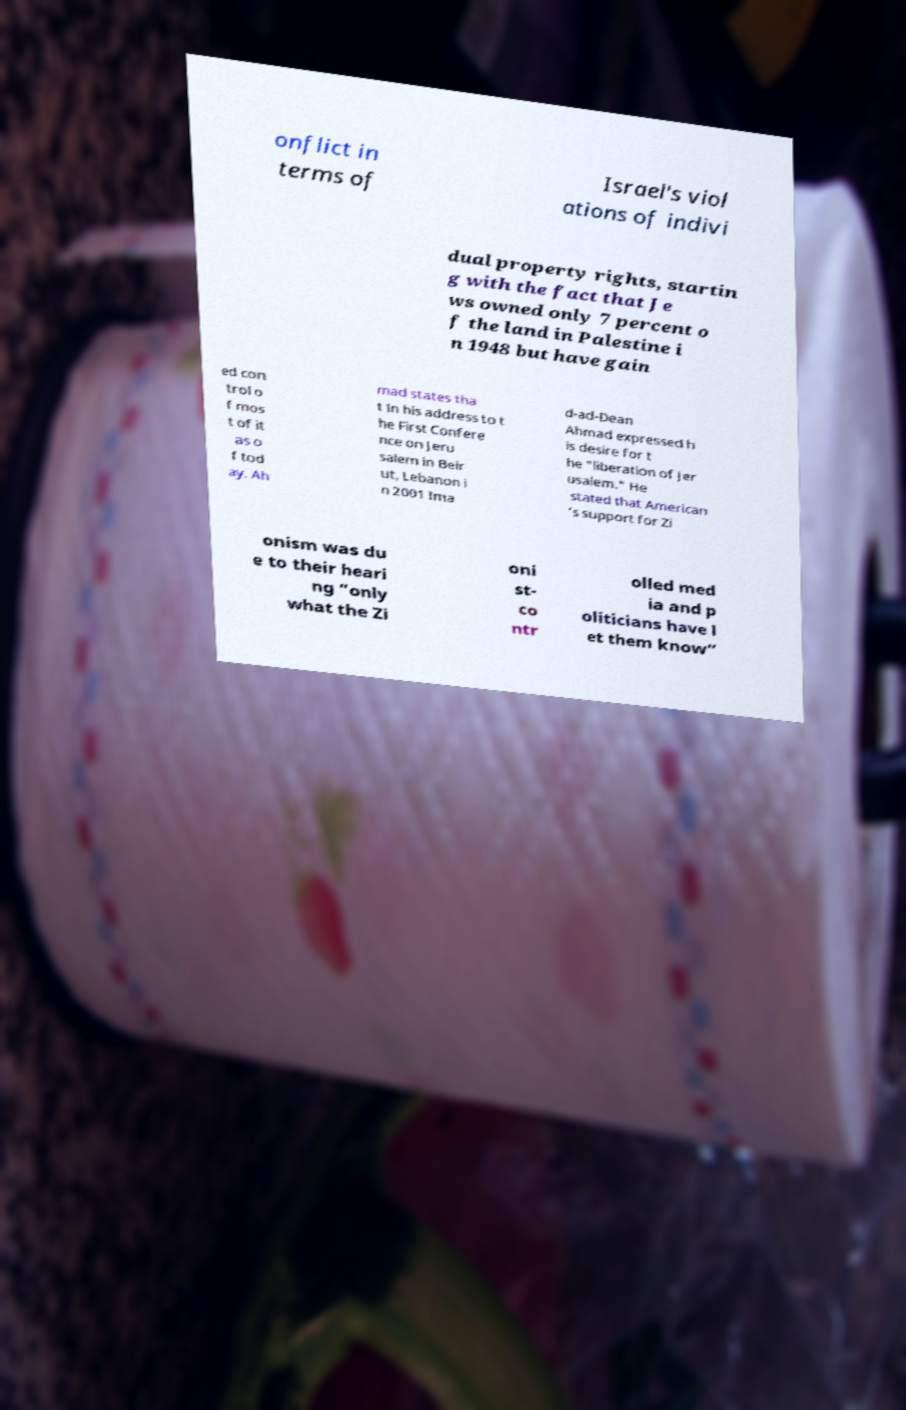Please identify and transcribe the text found in this image. onflict in terms of Israel's viol ations of indivi dual property rights, startin g with the fact that Je ws owned only 7 percent o f the land in Palestine i n 1948 but have gain ed con trol o f mos t of it as o f tod ay. Ah mad states tha t In his address to t he First Confere nce on Jeru salem in Beir ut, Lebanon i n 2001 Ima d-ad-Dean Ahmad expressed h is desire for t he "liberation of Jer usalem." He stated that American ’s support for Zi onism was du e to their heari ng “only what the Zi oni st- co ntr olled med ia and p oliticians have l et them know” 